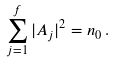Convert formula to latex. <formula><loc_0><loc_0><loc_500><loc_500>\sum _ { j = 1 } ^ { f } | A _ { j } | ^ { 2 } = n _ { 0 } \, .</formula> 